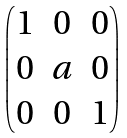<formula> <loc_0><loc_0><loc_500><loc_500>\begin{pmatrix} 1 & 0 & 0 \\ 0 & a & 0 \\ 0 & 0 & 1 \end{pmatrix}</formula> 